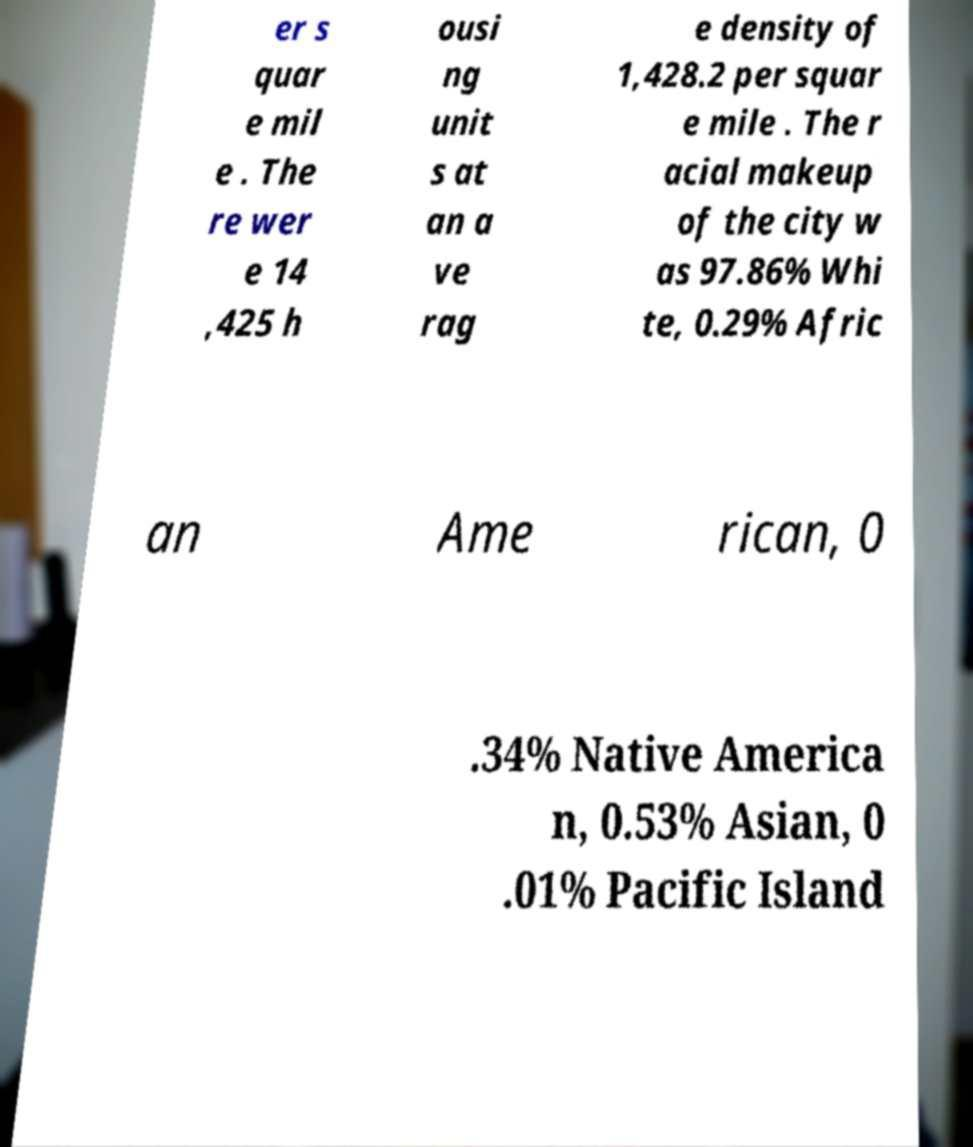Please identify and transcribe the text found in this image. er s quar e mil e . The re wer e 14 ,425 h ousi ng unit s at an a ve rag e density of 1,428.2 per squar e mile . The r acial makeup of the city w as 97.86% Whi te, 0.29% Afric an Ame rican, 0 .34% Native America n, 0.53% Asian, 0 .01% Pacific Island 